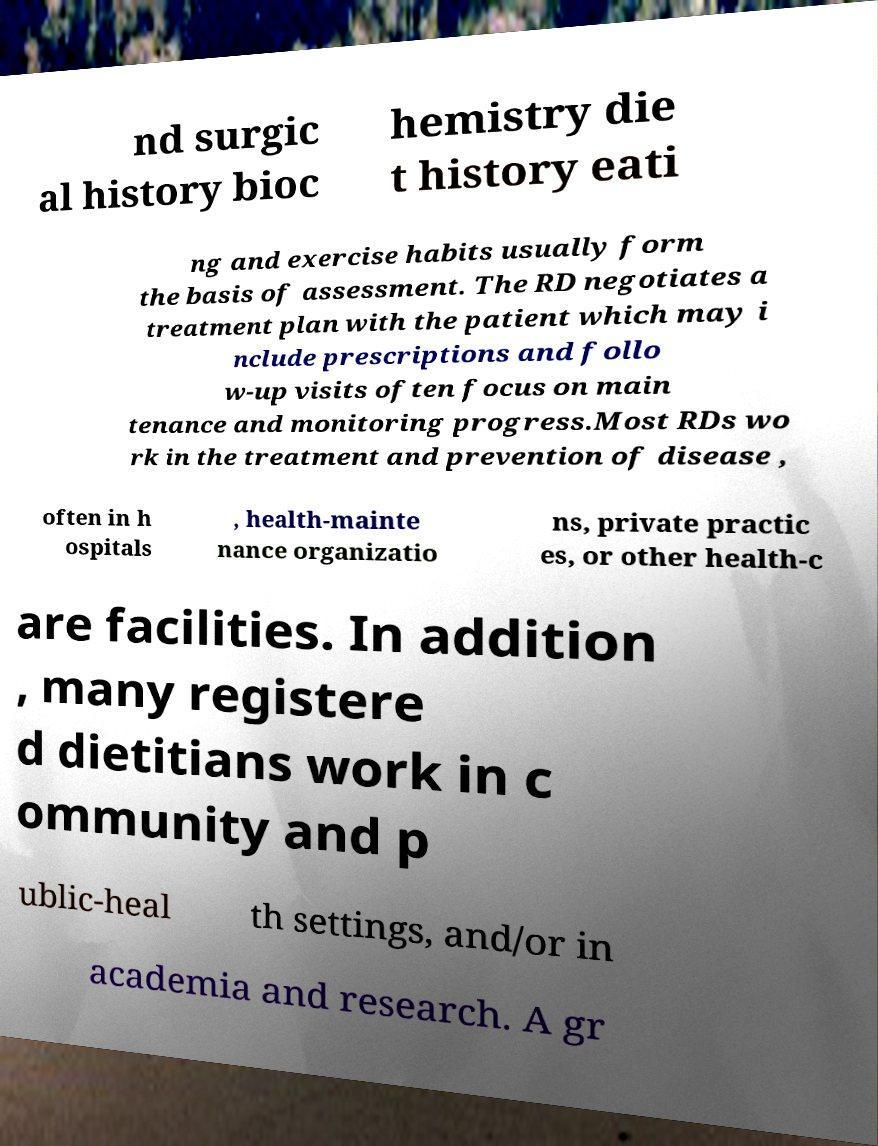What messages or text are displayed in this image? I need them in a readable, typed format. nd surgic al history bioc hemistry die t history eati ng and exercise habits usually form the basis of assessment. The RD negotiates a treatment plan with the patient which may i nclude prescriptions and follo w-up visits often focus on main tenance and monitoring progress.Most RDs wo rk in the treatment and prevention of disease , often in h ospitals , health-mainte nance organizatio ns, private practic es, or other health-c are facilities. In addition , many registere d dietitians work in c ommunity and p ublic-heal th settings, and/or in academia and research. A gr 